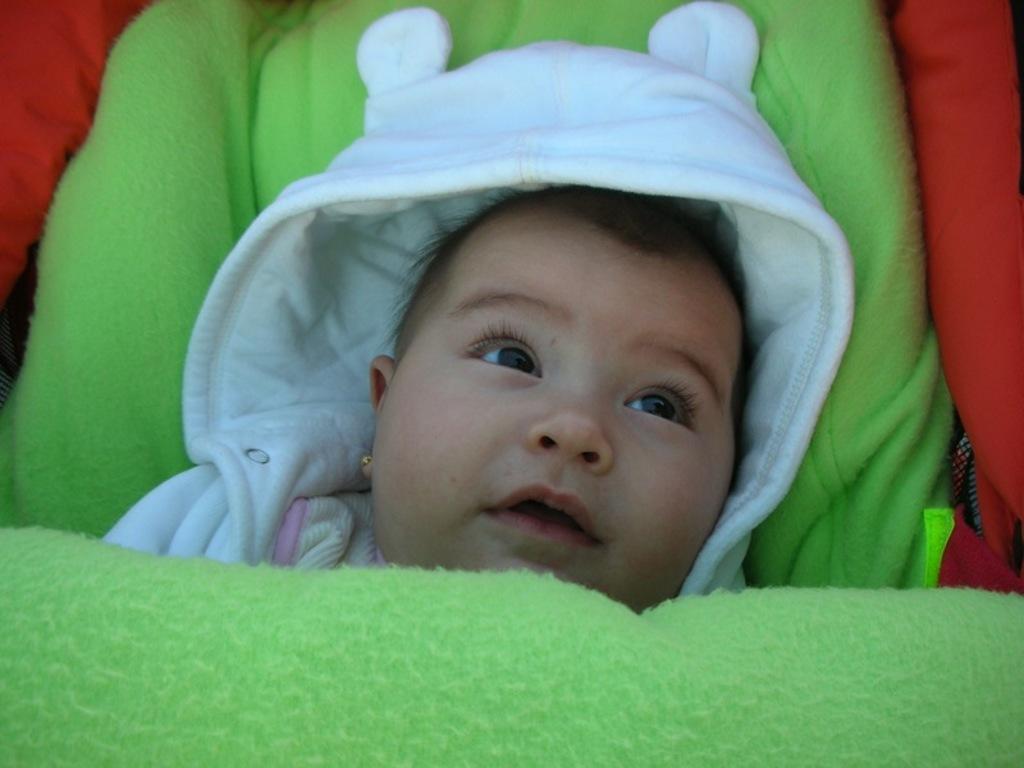How would you summarize this image in a sentence or two? In the middle of this image, there is a baby in a white color dress, on a light green color cloth. This baby is partially covered with a light green color cloth. In the background, there is an orange color cloth. 